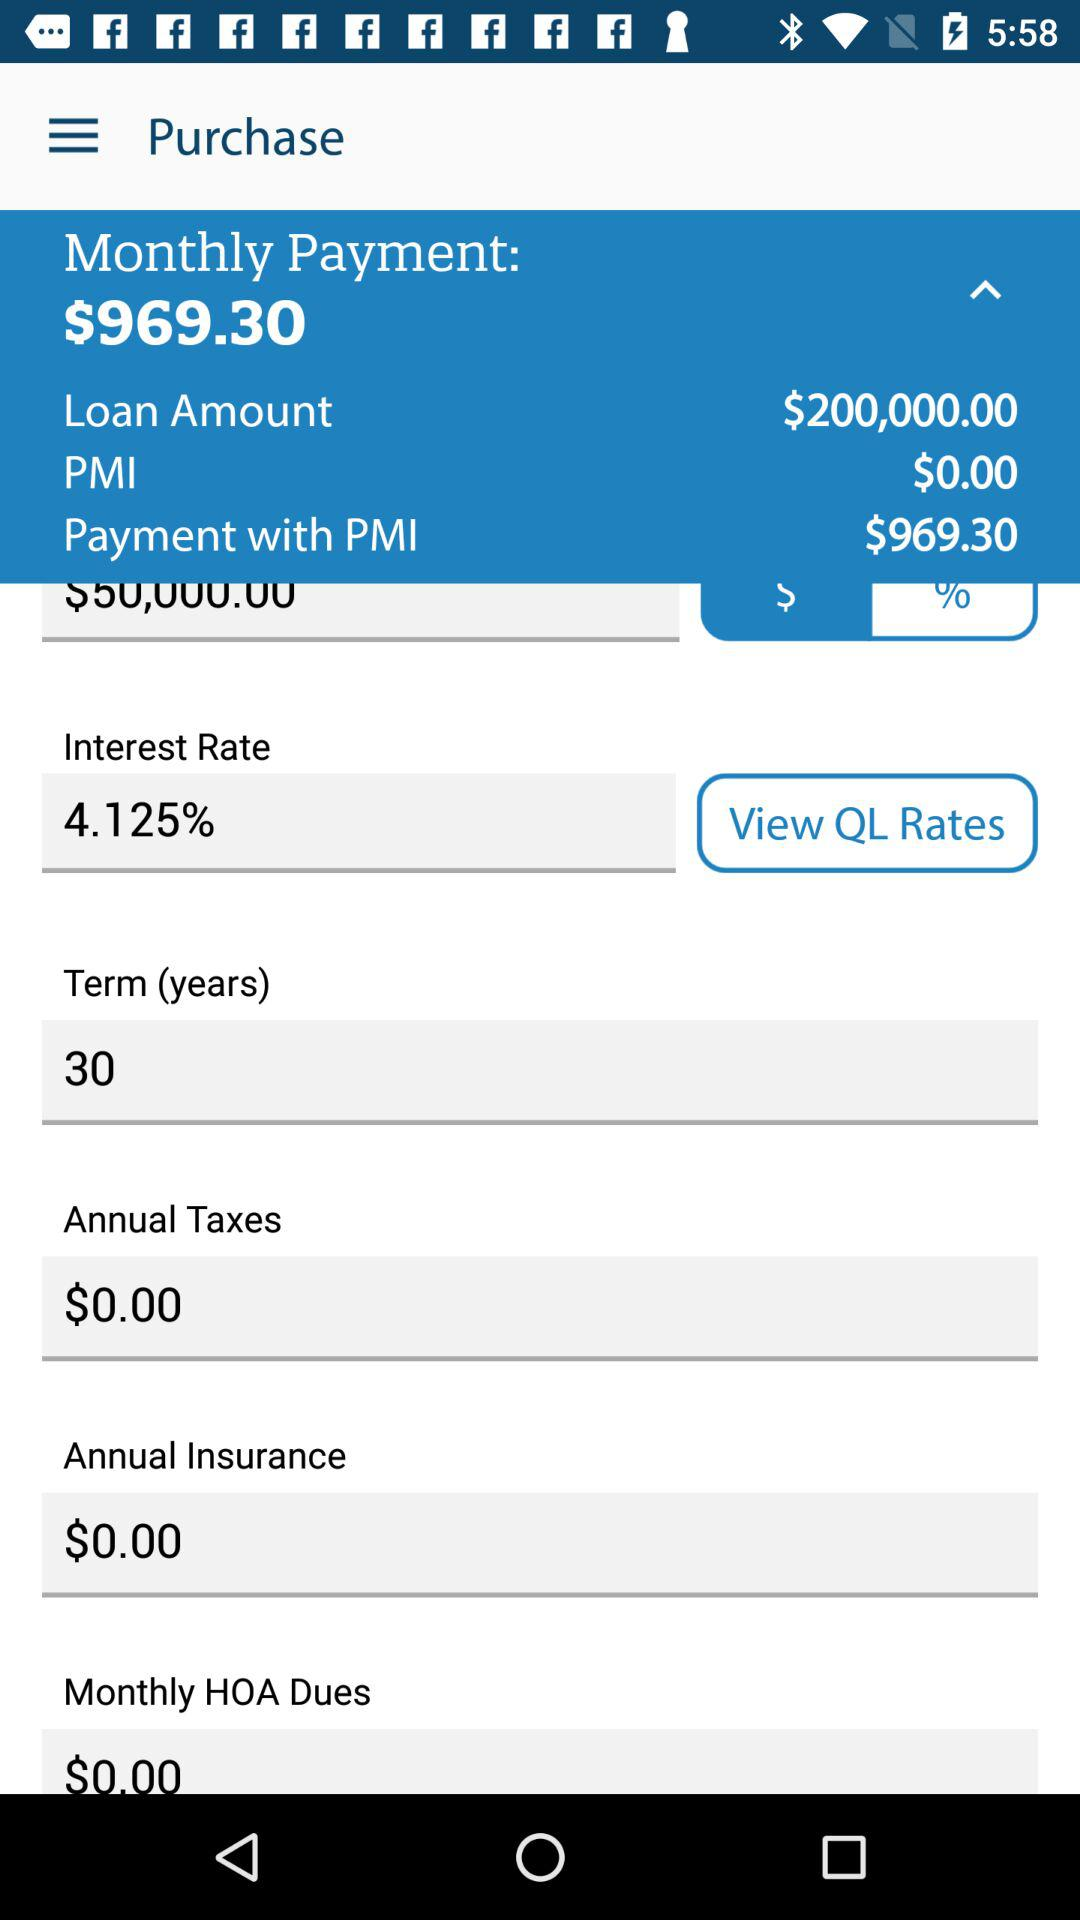What is the interest rate? The interest rate is 4.125%. 